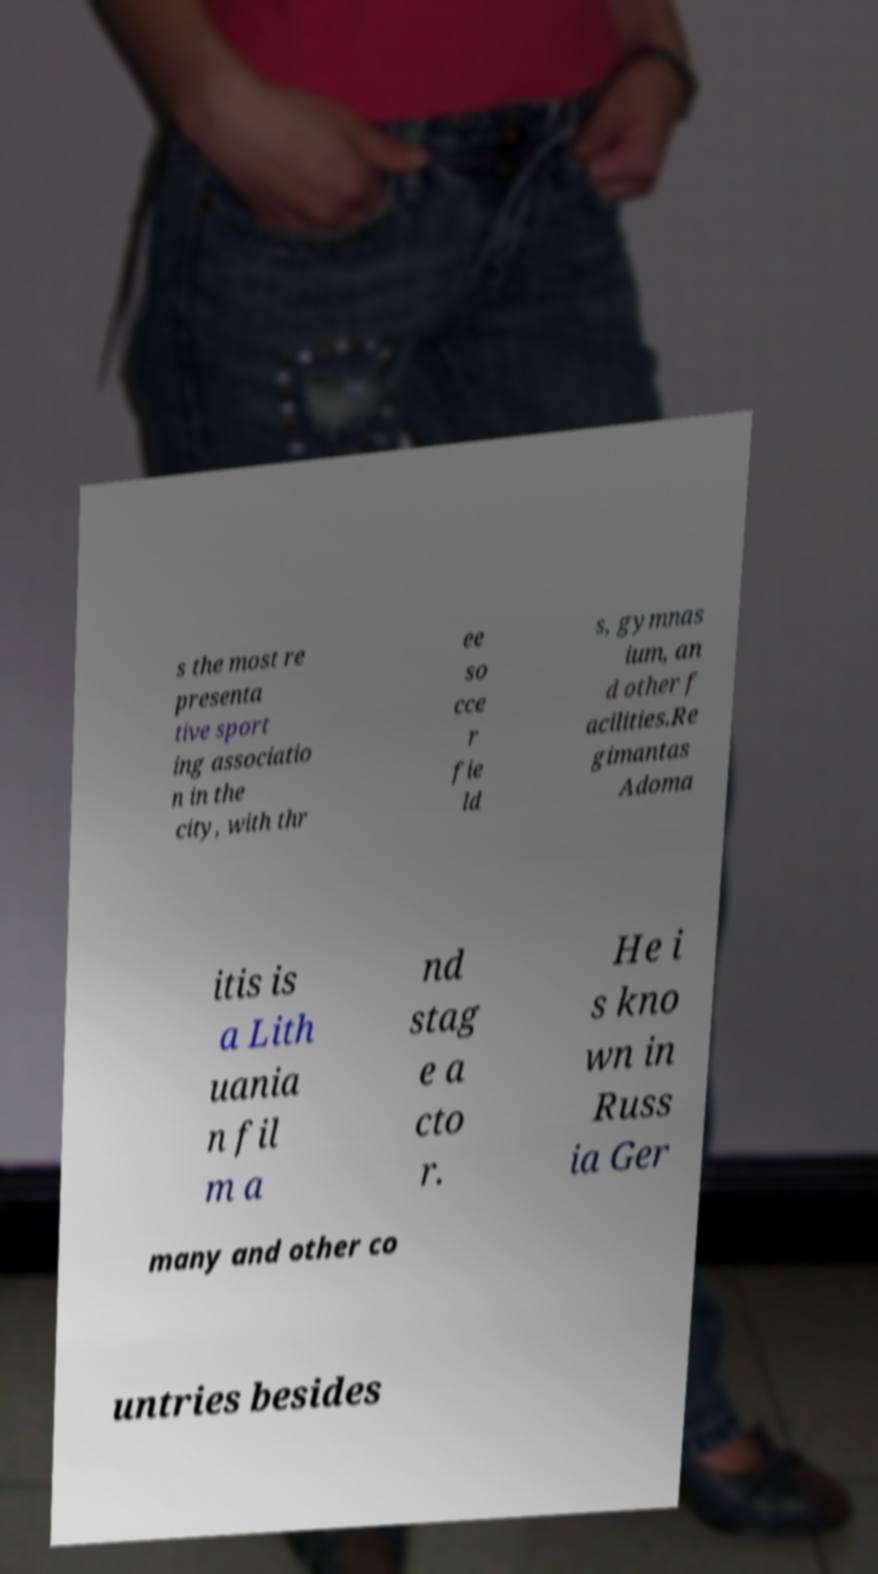Can you accurately transcribe the text from the provided image for me? s the most re presenta tive sport ing associatio n in the city, with thr ee so cce r fie ld s, gymnas ium, an d other f acilities.Re gimantas Adoma itis is a Lith uania n fil m a nd stag e a cto r. He i s kno wn in Russ ia Ger many and other co untries besides 